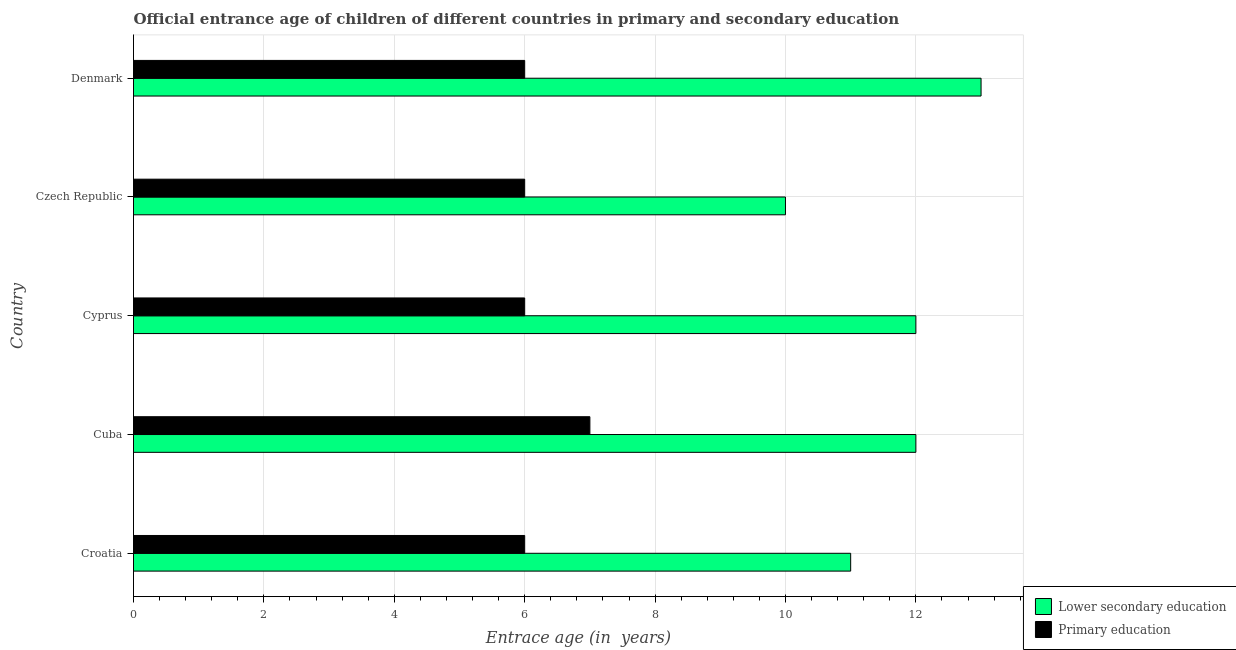Are the number of bars per tick equal to the number of legend labels?
Your answer should be very brief. Yes. Are the number of bars on each tick of the Y-axis equal?
Ensure brevity in your answer.  Yes. What is the label of the 5th group of bars from the top?
Make the answer very short. Croatia. What is the entrance age of children in lower secondary education in Croatia?
Ensure brevity in your answer.  11. Across all countries, what is the maximum entrance age of chiildren in primary education?
Give a very brief answer. 7. Across all countries, what is the minimum entrance age of children in lower secondary education?
Offer a very short reply. 10. In which country was the entrance age of chiildren in primary education maximum?
Provide a short and direct response. Cuba. In which country was the entrance age of chiildren in primary education minimum?
Your answer should be compact. Croatia. What is the total entrance age of children in lower secondary education in the graph?
Your response must be concise. 58. What is the difference between the entrance age of chiildren in primary education in Cuba and that in Denmark?
Offer a very short reply. 1. What is the difference between the entrance age of children in lower secondary education in Czech Republic and the entrance age of chiildren in primary education in Cyprus?
Your answer should be very brief. 4. What is the difference between the entrance age of chiildren in primary education and entrance age of children in lower secondary education in Czech Republic?
Your answer should be compact. -4. What is the ratio of the entrance age of children in lower secondary education in Croatia to that in Cyprus?
Ensure brevity in your answer.  0.92. Is the difference between the entrance age of chiildren in primary education in Cyprus and Denmark greater than the difference between the entrance age of children in lower secondary education in Cyprus and Denmark?
Your answer should be compact. Yes. What is the difference between the highest and the lowest entrance age of children in lower secondary education?
Your response must be concise. 3. In how many countries, is the entrance age of chiildren in primary education greater than the average entrance age of chiildren in primary education taken over all countries?
Offer a very short reply. 1. Is the sum of the entrance age of chiildren in primary education in Cuba and Cyprus greater than the maximum entrance age of children in lower secondary education across all countries?
Make the answer very short. No. What does the 2nd bar from the top in Cuba represents?
Your answer should be compact. Lower secondary education. What does the 1st bar from the bottom in Cuba represents?
Ensure brevity in your answer.  Lower secondary education. How many bars are there?
Your answer should be compact. 10. Are the values on the major ticks of X-axis written in scientific E-notation?
Provide a short and direct response. No. Does the graph contain any zero values?
Offer a very short reply. No. Where does the legend appear in the graph?
Give a very brief answer. Bottom right. What is the title of the graph?
Your answer should be compact. Official entrance age of children of different countries in primary and secondary education. What is the label or title of the X-axis?
Give a very brief answer. Entrace age (in  years). What is the Entrace age (in  years) of Lower secondary education in Croatia?
Provide a short and direct response. 11. What is the Entrace age (in  years) of Primary education in Cuba?
Your answer should be compact. 7. What is the Entrace age (in  years) in Primary education in Cyprus?
Your response must be concise. 6. What is the Entrace age (in  years) in Lower secondary education in Czech Republic?
Provide a succinct answer. 10. Across all countries, what is the maximum Entrace age (in  years) of Lower secondary education?
Your answer should be very brief. 13. Across all countries, what is the minimum Entrace age (in  years) of Lower secondary education?
Make the answer very short. 10. What is the total Entrace age (in  years) in Lower secondary education in the graph?
Make the answer very short. 58. What is the total Entrace age (in  years) of Primary education in the graph?
Your response must be concise. 31. What is the difference between the Entrace age (in  years) in Lower secondary education in Croatia and that in Cyprus?
Your answer should be compact. -1. What is the difference between the Entrace age (in  years) of Primary education in Croatia and that in Cyprus?
Offer a very short reply. 0. What is the difference between the Entrace age (in  years) in Primary education in Croatia and that in Czech Republic?
Make the answer very short. 0. What is the difference between the Entrace age (in  years) of Lower secondary education in Croatia and that in Denmark?
Offer a terse response. -2. What is the difference between the Entrace age (in  years) in Lower secondary education in Cuba and that in Cyprus?
Your response must be concise. 0. What is the difference between the Entrace age (in  years) of Lower secondary education in Cuba and that in Czech Republic?
Ensure brevity in your answer.  2. What is the difference between the Entrace age (in  years) in Primary education in Cuba and that in Czech Republic?
Ensure brevity in your answer.  1. What is the difference between the Entrace age (in  years) of Primary education in Cyprus and that in Czech Republic?
Give a very brief answer. 0. What is the difference between the Entrace age (in  years) of Primary education in Cyprus and that in Denmark?
Offer a terse response. 0. What is the difference between the Entrace age (in  years) in Primary education in Czech Republic and that in Denmark?
Your response must be concise. 0. What is the difference between the Entrace age (in  years) in Lower secondary education in Croatia and the Entrace age (in  years) in Primary education in Czech Republic?
Your response must be concise. 5. What is the difference between the Entrace age (in  years) of Lower secondary education in Croatia and the Entrace age (in  years) of Primary education in Denmark?
Keep it short and to the point. 5. What is the difference between the Entrace age (in  years) in Lower secondary education in Cuba and the Entrace age (in  years) in Primary education in Denmark?
Your response must be concise. 6. What is the difference between the Entrace age (in  years) in Lower secondary education in Cyprus and the Entrace age (in  years) in Primary education in Denmark?
Offer a terse response. 6. What is the difference between the Entrace age (in  years) in Lower secondary education in Czech Republic and the Entrace age (in  years) in Primary education in Denmark?
Ensure brevity in your answer.  4. What is the average Entrace age (in  years) in Lower secondary education per country?
Make the answer very short. 11.6. What is the average Entrace age (in  years) in Primary education per country?
Your answer should be very brief. 6.2. What is the difference between the Entrace age (in  years) of Lower secondary education and Entrace age (in  years) of Primary education in Cyprus?
Make the answer very short. 6. What is the difference between the Entrace age (in  years) in Lower secondary education and Entrace age (in  years) in Primary education in Czech Republic?
Provide a short and direct response. 4. What is the ratio of the Entrace age (in  years) in Lower secondary education in Croatia to that in Cuba?
Keep it short and to the point. 0.92. What is the ratio of the Entrace age (in  years) of Lower secondary education in Croatia to that in Czech Republic?
Provide a succinct answer. 1.1. What is the ratio of the Entrace age (in  years) in Primary education in Croatia to that in Czech Republic?
Your answer should be very brief. 1. What is the ratio of the Entrace age (in  years) in Lower secondary education in Croatia to that in Denmark?
Offer a terse response. 0.85. What is the ratio of the Entrace age (in  years) in Lower secondary education in Cuba to that in Cyprus?
Your answer should be very brief. 1. What is the ratio of the Entrace age (in  years) of Lower secondary education in Cuba to that in Czech Republic?
Offer a terse response. 1.2. What is the ratio of the Entrace age (in  years) of Primary education in Cuba to that in Czech Republic?
Offer a terse response. 1.17. What is the ratio of the Entrace age (in  years) in Lower secondary education in Cuba to that in Denmark?
Your response must be concise. 0.92. What is the ratio of the Entrace age (in  years) in Primary education in Cuba to that in Denmark?
Provide a succinct answer. 1.17. What is the ratio of the Entrace age (in  years) of Primary education in Cyprus to that in Czech Republic?
Your answer should be very brief. 1. What is the ratio of the Entrace age (in  years) in Primary education in Cyprus to that in Denmark?
Provide a short and direct response. 1. What is the ratio of the Entrace age (in  years) of Lower secondary education in Czech Republic to that in Denmark?
Your answer should be very brief. 0.77. What is the ratio of the Entrace age (in  years) of Primary education in Czech Republic to that in Denmark?
Give a very brief answer. 1. What is the difference between the highest and the second highest Entrace age (in  years) of Primary education?
Offer a terse response. 1. What is the difference between the highest and the lowest Entrace age (in  years) in Lower secondary education?
Offer a very short reply. 3. 